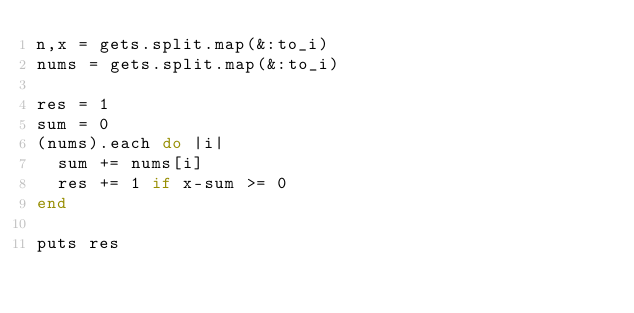<code> <loc_0><loc_0><loc_500><loc_500><_Ruby_>n,x = gets.split.map(&:to_i)
nums = gets.split.map(&:to_i)
 
res = 1
sum = 0
(nums).each do |i|
  sum += nums[i]
  res += 1 if x-sum >= 0
end
 
puts res</code> 